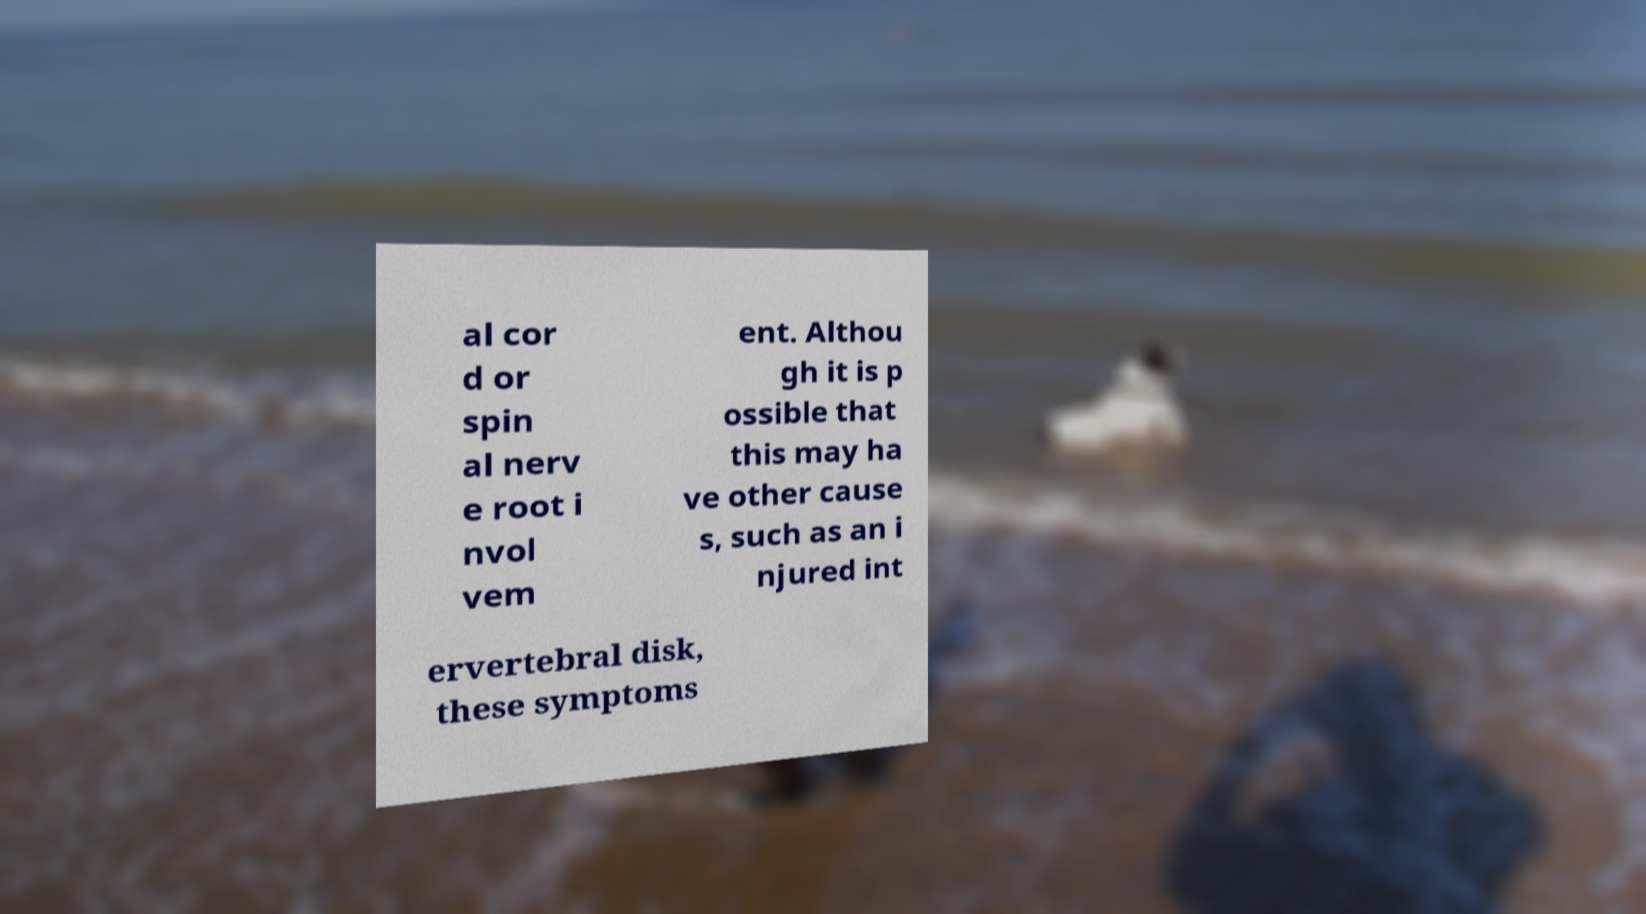Can you read and provide the text displayed in the image?This photo seems to have some interesting text. Can you extract and type it out for me? al cor d or spin al nerv e root i nvol vem ent. Althou gh it is p ossible that this may ha ve other cause s, such as an i njured int ervertebral disk, these symptoms 